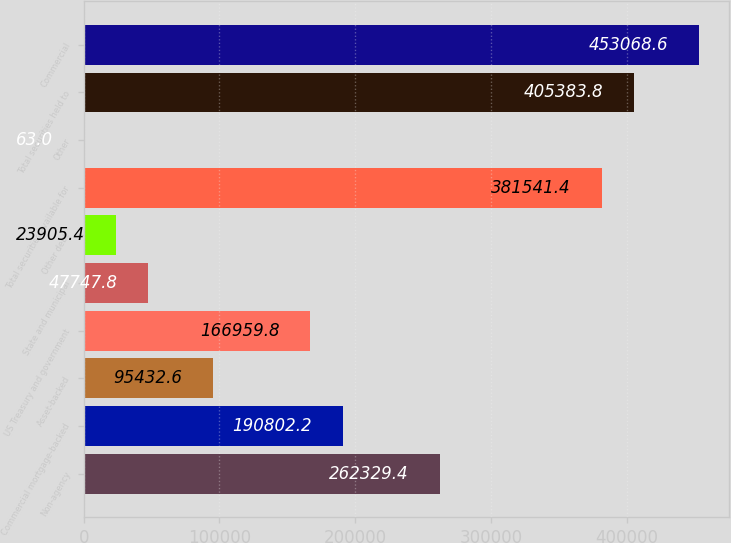<chart> <loc_0><loc_0><loc_500><loc_500><bar_chart><fcel>Non-agency<fcel>Commercial mortgage-backed<fcel>Asset-backed<fcel>US Treasury and government<fcel>State and municipal<fcel>Other debt<fcel>Total securities available for<fcel>Other<fcel>Total securities held to<fcel>Commercial<nl><fcel>262329<fcel>190802<fcel>95432.6<fcel>166960<fcel>47747.8<fcel>23905.4<fcel>381541<fcel>63<fcel>405384<fcel>453069<nl></chart> 